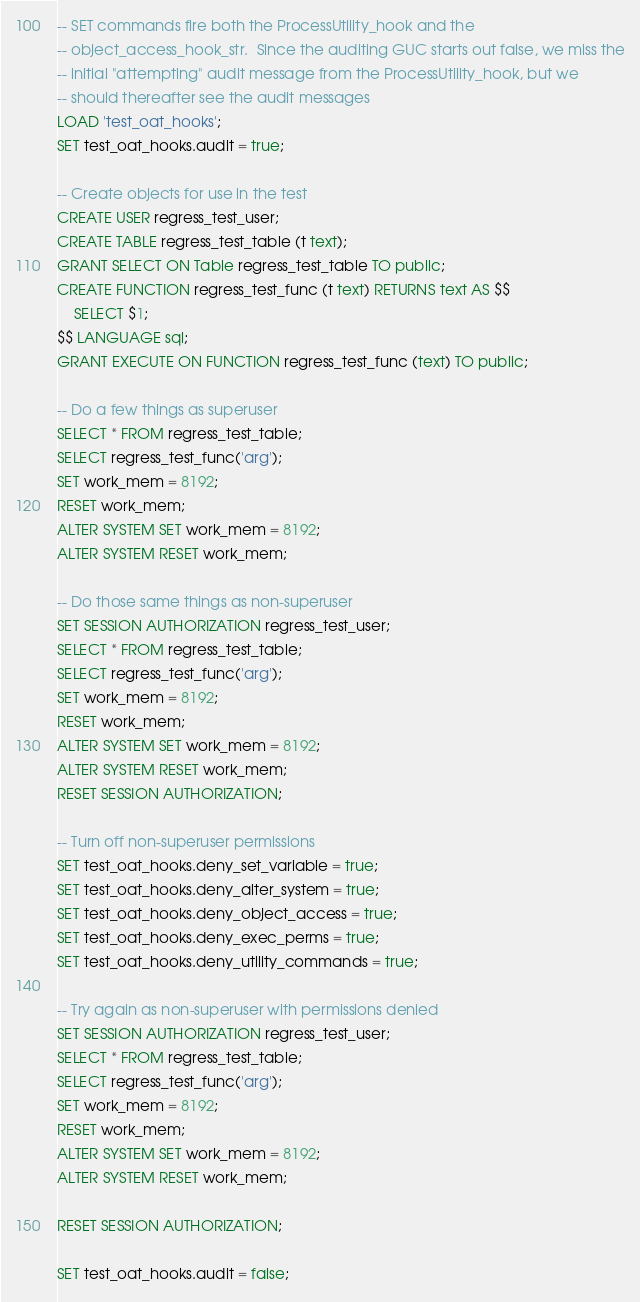Convert code to text. <code><loc_0><loc_0><loc_500><loc_500><_SQL_>-- SET commands fire both the ProcessUtility_hook and the
-- object_access_hook_str.  Since the auditing GUC starts out false, we miss the
-- initial "attempting" audit message from the ProcessUtility_hook, but we
-- should thereafter see the audit messages
LOAD 'test_oat_hooks';
SET test_oat_hooks.audit = true;

-- Create objects for use in the test
CREATE USER regress_test_user;
CREATE TABLE regress_test_table (t text);
GRANT SELECT ON Table regress_test_table TO public;
CREATE FUNCTION regress_test_func (t text) RETURNS text AS $$
	SELECT $1;
$$ LANGUAGE sql;
GRANT EXECUTE ON FUNCTION regress_test_func (text) TO public;

-- Do a few things as superuser
SELECT * FROM regress_test_table;
SELECT regress_test_func('arg');
SET work_mem = 8192;
RESET work_mem;
ALTER SYSTEM SET work_mem = 8192;
ALTER SYSTEM RESET work_mem;

-- Do those same things as non-superuser
SET SESSION AUTHORIZATION regress_test_user;
SELECT * FROM regress_test_table;
SELECT regress_test_func('arg');
SET work_mem = 8192;
RESET work_mem;
ALTER SYSTEM SET work_mem = 8192;
ALTER SYSTEM RESET work_mem;
RESET SESSION AUTHORIZATION;

-- Turn off non-superuser permissions
SET test_oat_hooks.deny_set_variable = true;
SET test_oat_hooks.deny_alter_system = true;
SET test_oat_hooks.deny_object_access = true;
SET test_oat_hooks.deny_exec_perms = true;
SET test_oat_hooks.deny_utility_commands = true;

-- Try again as non-superuser with permissions denied
SET SESSION AUTHORIZATION regress_test_user;
SELECT * FROM regress_test_table;
SELECT regress_test_func('arg');
SET work_mem = 8192;
RESET work_mem;
ALTER SYSTEM SET work_mem = 8192;
ALTER SYSTEM RESET work_mem;

RESET SESSION AUTHORIZATION;

SET test_oat_hooks.audit = false;
</code> 